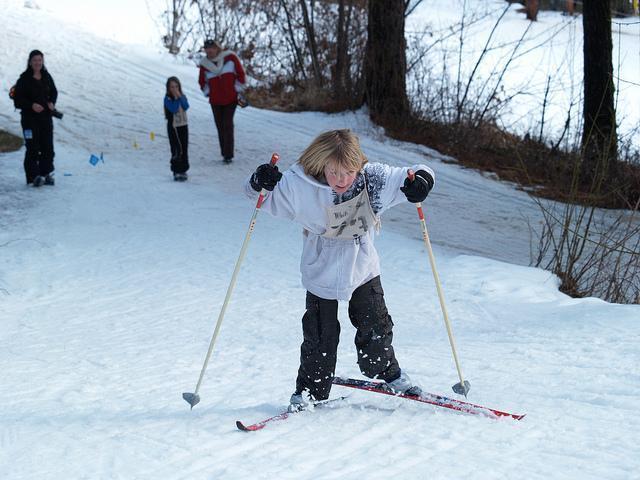How many people are there?
Give a very brief answer. 4. How many panel partitions on the blue umbrella have writing on them?
Give a very brief answer. 0. 